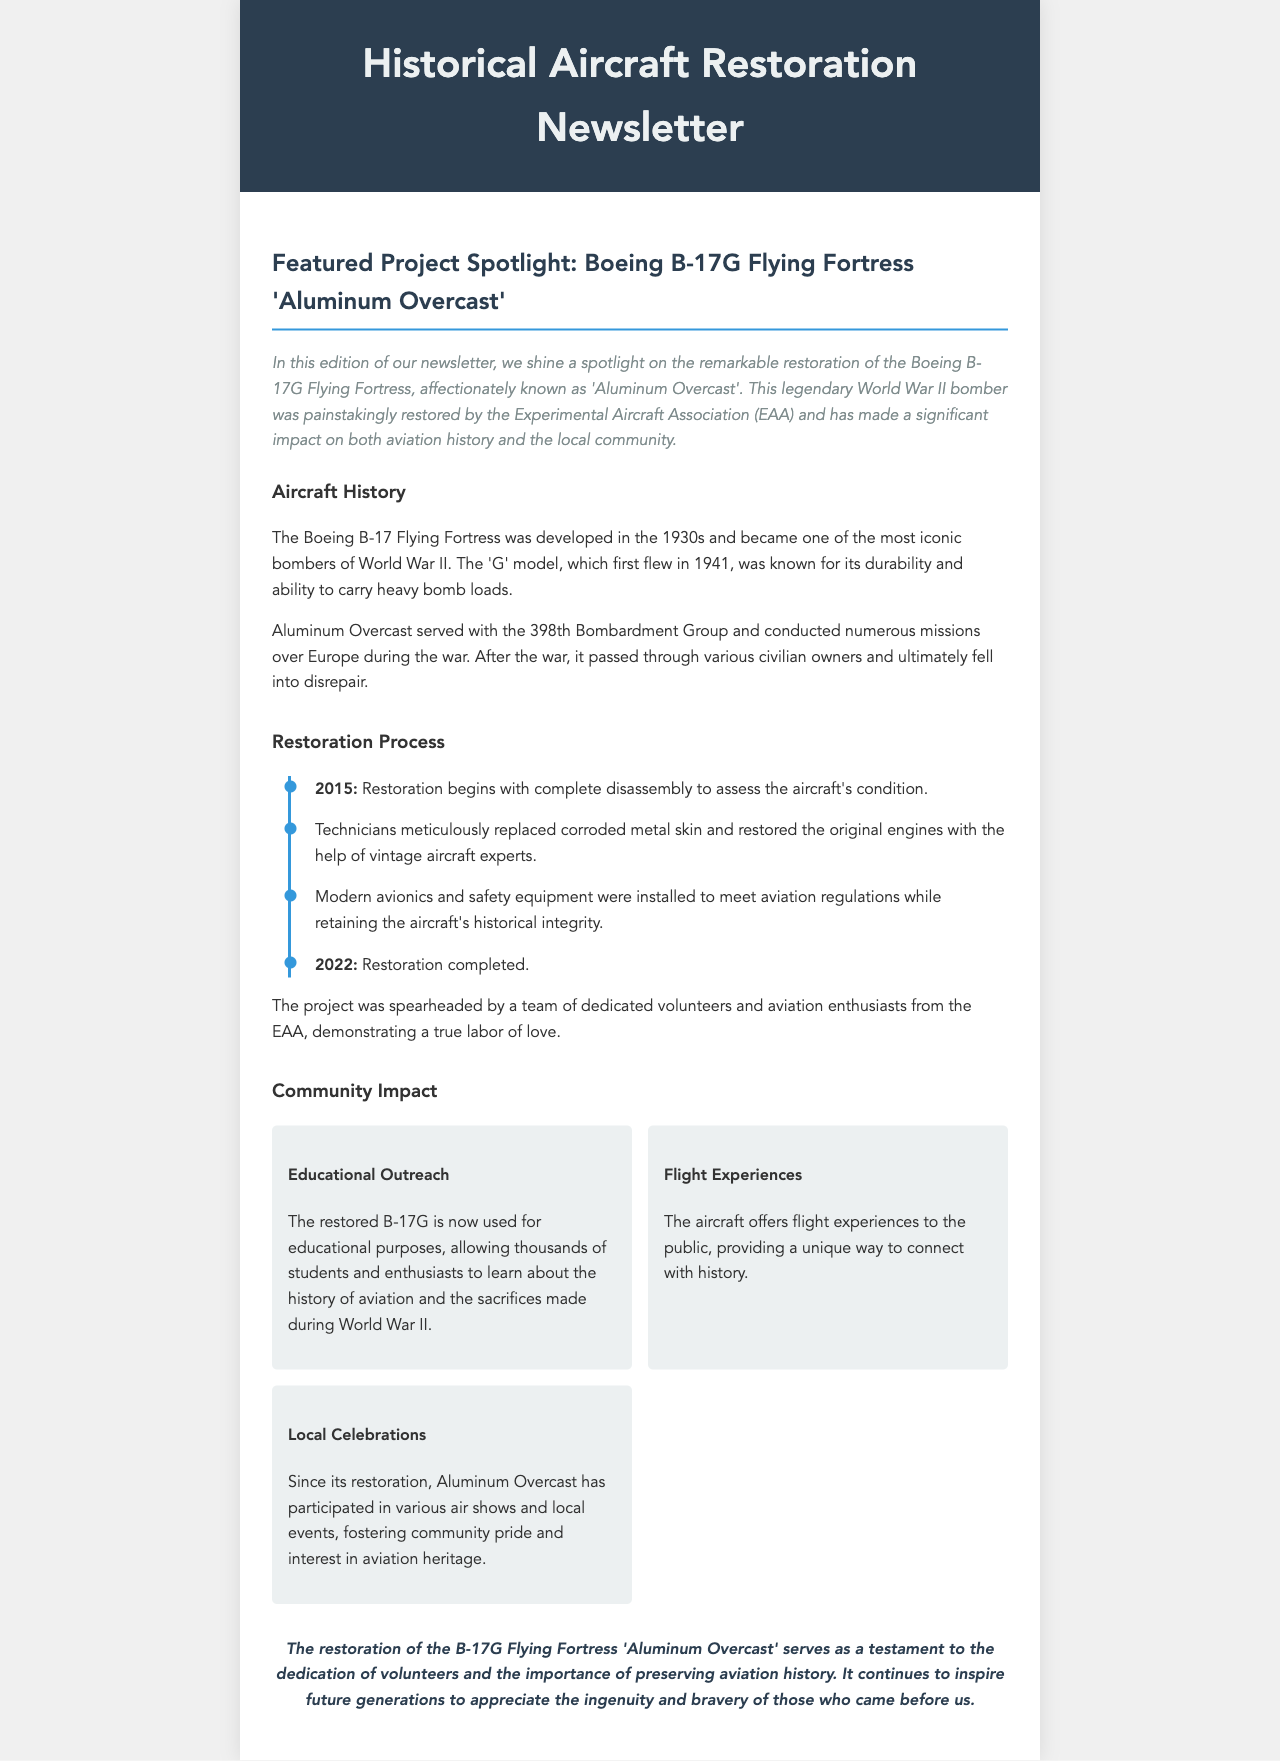What is the name of the restored aircraft? The name of the restored aircraft is mentioned in the title of the spotlight section of the newsletter.
Answer: Aluminum Overcast When did the restoration begin? The restoration timeline mentions the year when the restoration process started.
Answer: 2015 Who spearheaded the restoration project? The newsletter specifies the organization responsible for leading the restoration efforts.
Answer: Experimental Aircraft Association (EAA) What model of the aircraft is featured in the spotlight? The newsletter delineates the specific model of the aircraft that has been restored.
Answer: B-17G Flying Fortress In what year was the restoration completed? The timeline includes the year marking the completion of the restoration process.
Answer: 2022 What is one purpose of the restored B-17G? The newsletter lists the uses of the restored aircraft, including educational outreach.
Answer: Educational Outreach How many items are in the community impact section? The document provides three distinct points under the community impact section.
Answer: Three What is the significance of Aluminum Overcast's restoration? The newsletter concludes with a statement about the greater meaning behind the restoration project.
Answer: Dedication of volunteers What month in what year did the B-17G first fly? The history section specifies the context and time of the 'G' model's first flight.
Answer: 1941 